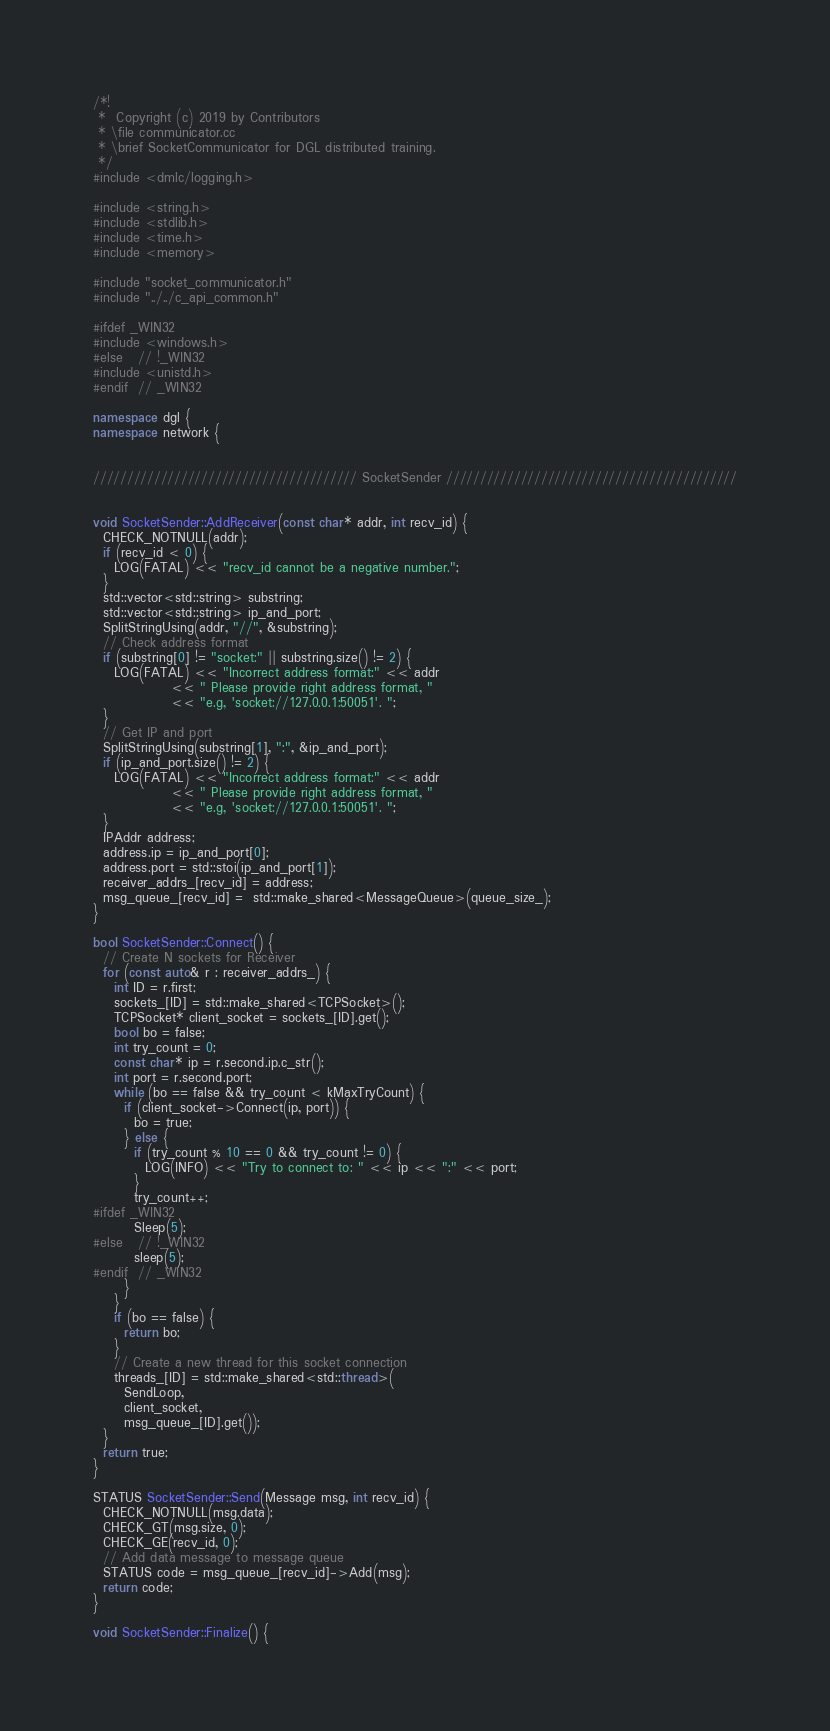Convert code to text. <code><loc_0><loc_0><loc_500><loc_500><_C++_>/*!
 *  Copyright (c) 2019 by Contributors
 * \file communicator.cc
 * \brief SocketCommunicator for DGL distributed training.
 */
#include <dmlc/logging.h>

#include <string.h>
#include <stdlib.h>
#include <time.h>
#include <memory>

#include "socket_communicator.h"
#include "../../c_api_common.h"

#ifdef _WIN32
#include <windows.h>
#else   // !_WIN32
#include <unistd.h>
#endif  // _WIN32

namespace dgl {
namespace network {


/////////////////////////////////////// SocketSender ///////////////////////////////////////////


void SocketSender::AddReceiver(const char* addr, int recv_id) {
  CHECK_NOTNULL(addr);
  if (recv_id < 0) {
    LOG(FATAL) << "recv_id cannot be a negative number.";
  }
  std::vector<std::string> substring;
  std::vector<std::string> ip_and_port;
  SplitStringUsing(addr, "//", &substring);
  // Check address format
  if (substring[0] != "socket:" || substring.size() != 2) {
    LOG(FATAL) << "Incorrect address format:" << addr
               << " Please provide right address format, "
               << "e.g, 'socket://127.0.0.1:50051'. ";
  }
  // Get IP and port
  SplitStringUsing(substring[1], ":", &ip_and_port);
  if (ip_and_port.size() != 2) {
    LOG(FATAL) << "Incorrect address format:" << addr
               << " Please provide right address format, "
               << "e.g, 'socket://127.0.0.1:50051'. ";
  }
  IPAddr address;
  address.ip = ip_and_port[0];
  address.port = std::stoi(ip_and_port[1]);
  receiver_addrs_[recv_id] = address;
  msg_queue_[recv_id] =  std::make_shared<MessageQueue>(queue_size_);
}

bool SocketSender::Connect() {
  // Create N sockets for Receiver
  for (const auto& r : receiver_addrs_) {
    int ID = r.first;
    sockets_[ID] = std::make_shared<TCPSocket>();
    TCPSocket* client_socket = sockets_[ID].get();
    bool bo = false;
    int try_count = 0;
    const char* ip = r.second.ip.c_str();
    int port = r.second.port;
    while (bo == false && try_count < kMaxTryCount) {
      if (client_socket->Connect(ip, port)) {
        bo = true;
      } else {
        if (try_count % 10 == 0 && try_count != 0) {
          LOG(INFO) << "Try to connect to: " << ip << ":" << port;
        }
        try_count++;
#ifdef _WIN32
        Sleep(5);
#else   // !_WIN32
        sleep(5);
#endif  // _WIN32
      }
    }
    if (bo == false) {
      return bo;
    }
    // Create a new thread for this socket connection
    threads_[ID] = std::make_shared<std::thread>(
      SendLoop,
      client_socket,
      msg_queue_[ID].get());
  }
  return true;
}

STATUS SocketSender::Send(Message msg, int recv_id) {
  CHECK_NOTNULL(msg.data);
  CHECK_GT(msg.size, 0);
  CHECK_GE(recv_id, 0);
  // Add data message to message queue
  STATUS code = msg_queue_[recv_id]->Add(msg);
  return code;
}

void SocketSender::Finalize() {</code> 